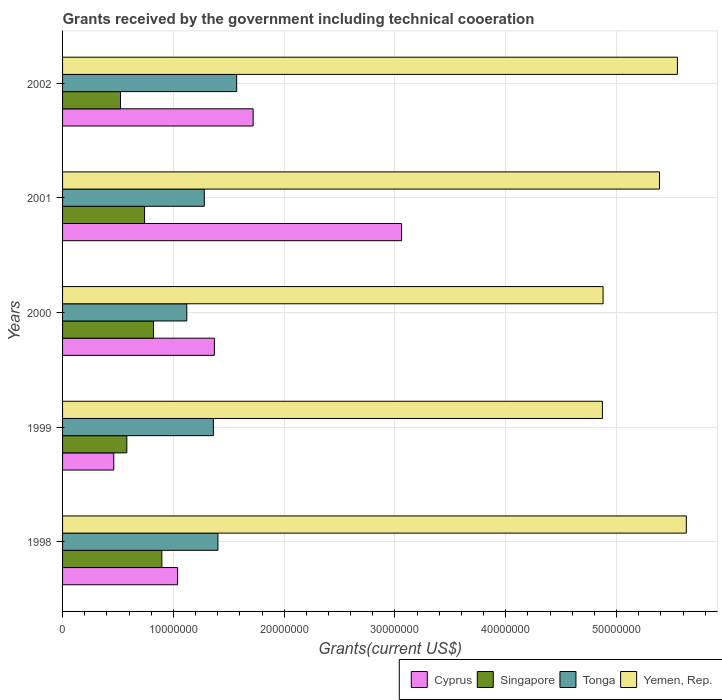How many different coloured bars are there?
Offer a terse response. 4. Are the number of bars per tick equal to the number of legend labels?
Your response must be concise. Yes. Are the number of bars on each tick of the Y-axis equal?
Keep it short and to the point. Yes. How many bars are there on the 2nd tick from the top?
Give a very brief answer. 4. In how many cases, is the number of bars for a given year not equal to the number of legend labels?
Offer a very short reply. 0. What is the total grants received by the government in Singapore in 2001?
Ensure brevity in your answer.  7.40e+06. Across all years, what is the maximum total grants received by the government in Yemen, Rep.?
Give a very brief answer. 5.63e+07. Across all years, what is the minimum total grants received by the government in Yemen, Rep.?
Offer a very short reply. 4.87e+07. In which year was the total grants received by the government in Yemen, Rep. maximum?
Your answer should be compact. 1998. In which year was the total grants received by the government in Singapore minimum?
Provide a short and direct response. 2002. What is the total total grants received by the government in Yemen, Rep. in the graph?
Make the answer very short. 2.63e+08. What is the difference between the total grants received by the government in Yemen, Rep. in 1998 and that in 2000?
Make the answer very short. 7.51e+06. What is the difference between the total grants received by the government in Yemen, Rep. in 2001 and the total grants received by the government in Cyprus in 2002?
Your response must be concise. 3.67e+07. What is the average total grants received by the government in Tonga per year?
Offer a very short reply. 1.35e+07. In the year 2001, what is the difference between the total grants received by the government in Yemen, Rep. and total grants received by the government in Cyprus?
Your answer should be compact. 2.33e+07. What is the ratio of the total grants received by the government in Cyprus in 1999 to that in 2002?
Keep it short and to the point. 0.27. Is the difference between the total grants received by the government in Yemen, Rep. in 1999 and 2001 greater than the difference between the total grants received by the government in Cyprus in 1999 and 2001?
Make the answer very short. Yes. What is the difference between the highest and the second highest total grants received by the government in Yemen, Rep.?
Ensure brevity in your answer.  8.00e+05. What is the difference between the highest and the lowest total grants received by the government in Yemen, Rep.?
Provide a succinct answer. 7.57e+06. Is the sum of the total grants received by the government in Cyprus in 1999 and 2000 greater than the maximum total grants received by the government in Singapore across all years?
Make the answer very short. Yes. Is it the case that in every year, the sum of the total grants received by the government in Cyprus and total grants received by the government in Singapore is greater than the sum of total grants received by the government in Tonga and total grants received by the government in Yemen, Rep.?
Your answer should be very brief. No. What does the 2nd bar from the top in 1998 represents?
Ensure brevity in your answer.  Tonga. What does the 2nd bar from the bottom in 1999 represents?
Your answer should be compact. Singapore. How many bars are there?
Your answer should be very brief. 20. Are all the bars in the graph horizontal?
Provide a short and direct response. Yes. Are the values on the major ticks of X-axis written in scientific E-notation?
Your answer should be very brief. No. Does the graph contain any zero values?
Your answer should be very brief. No. Where does the legend appear in the graph?
Offer a very short reply. Bottom right. What is the title of the graph?
Provide a short and direct response. Grants received by the government including technical cooeration. Does "Czech Republic" appear as one of the legend labels in the graph?
Offer a very short reply. No. What is the label or title of the X-axis?
Your answer should be compact. Grants(current US$). What is the Grants(current US$) of Cyprus in 1998?
Provide a succinct answer. 1.04e+07. What is the Grants(current US$) in Singapore in 1998?
Your answer should be compact. 8.96e+06. What is the Grants(current US$) in Tonga in 1998?
Your response must be concise. 1.40e+07. What is the Grants(current US$) in Yemen, Rep. in 1998?
Provide a succinct answer. 5.63e+07. What is the Grants(current US$) in Cyprus in 1999?
Your answer should be compact. 4.62e+06. What is the Grants(current US$) in Singapore in 1999?
Provide a succinct answer. 5.80e+06. What is the Grants(current US$) of Tonga in 1999?
Offer a very short reply. 1.36e+07. What is the Grants(current US$) in Yemen, Rep. in 1999?
Provide a short and direct response. 4.87e+07. What is the Grants(current US$) in Cyprus in 2000?
Offer a terse response. 1.37e+07. What is the Grants(current US$) of Singapore in 2000?
Ensure brevity in your answer.  8.21e+06. What is the Grants(current US$) of Tonga in 2000?
Offer a terse response. 1.12e+07. What is the Grants(current US$) in Yemen, Rep. in 2000?
Ensure brevity in your answer.  4.88e+07. What is the Grants(current US$) in Cyprus in 2001?
Keep it short and to the point. 3.06e+07. What is the Grants(current US$) of Singapore in 2001?
Keep it short and to the point. 7.40e+06. What is the Grants(current US$) of Tonga in 2001?
Provide a short and direct response. 1.28e+07. What is the Grants(current US$) in Yemen, Rep. in 2001?
Keep it short and to the point. 5.39e+07. What is the Grants(current US$) of Cyprus in 2002?
Your answer should be compact. 1.72e+07. What is the Grants(current US$) in Singapore in 2002?
Ensure brevity in your answer.  5.23e+06. What is the Grants(current US$) of Tonga in 2002?
Ensure brevity in your answer.  1.57e+07. What is the Grants(current US$) in Yemen, Rep. in 2002?
Your response must be concise. 5.55e+07. Across all years, what is the maximum Grants(current US$) of Cyprus?
Provide a succinct answer. 3.06e+07. Across all years, what is the maximum Grants(current US$) of Singapore?
Offer a very short reply. 8.96e+06. Across all years, what is the maximum Grants(current US$) in Tonga?
Offer a very short reply. 1.57e+07. Across all years, what is the maximum Grants(current US$) in Yemen, Rep.?
Your answer should be compact. 5.63e+07. Across all years, what is the minimum Grants(current US$) of Cyprus?
Make the answer very short. 4.62e+06. Across all years, what is the minimum Grants(current US$) of Singapore?
Make the answer very short. 5.23e+06. Across all years, what is the minimum Grants(current US$) in Tonga?
Offer a terse response. 1.12e+07. Across all years, what is the minimum Grants(current US$) in Yemen, Rep.?
Your answer should be very brief. 4.87e+07. What is the total Grants(current US$) in Cyprus in the graph?
Provide a short and direct response. 7.65e+07. What is the total Grants(current US$) of Singapore in the graph?
Provide a short and direct response. 3.56e+07. What is the total Grants(current US$) of Tonga in the graph?
Offer a terse response. 6.73e+07. What is the total Grants(current US$) of Yemen, Rep. in the graph?
Make the answer very short. 2.63e+08. What is the difference between the Grants(current US$) in Cyprus in 1998 and that in 1999?
Ensure brevity in your answer.  5.76e+06. What is the difference between the Grants(current US$) of Singapore in 1998 and that in 1999?
Your answer should be compact. 3.16e+06. What is the difference between the Grants(current US$) of Yemen, Rep. in 1998 and that in 1999?
Your answer should be very brief. 7.57e+06. What is the difference between the Grants(current US$) of Cyprus in 1998 and that in 2000?
Your answer should be very brief. -3.32e+06. What is the difference between the Grants(current US$) in Singapore in 1998 and that in 2000?
Provide a succinct answer. 7.50e+05. What is the difference between the Grants(current US$) in Tonga in 1998 and that in 2000?
Provide a succinct answer. 2.81e+06. What is the difference between the Grants(current US$) in Yemen, Rep. in 1998 and that in 2000?
Your answer should be compact. 7.51e+06. What is the difference between the Grants(current US$) of Cyprus in 1998 and that in 2001?
Your answer should be compact. -2.02e+07. What is the difference between the Grants(current US$) in Singapore in 1998 and that in 2001?
Your answer should be very brief. 1.56e+06. What is the difference between the Grants(current US$) of Tonga in 1998 and that in 2001?
Your answer should be very brief. 1.23e+06. What is the difference between the Grants(current US$) in Yemen, Rep. in 1998 and that in 2001?
Your answer should be very brief. 2.42e+06. What is the difference between the Grants(current US$) of Cyprus in 1998 and that in 2002?
Ensure brevity in your answer.  -6.82e+06. What is the difference between the Grants(current US$) in Singapore in 1998 and that in 2002?
Offer a very short reply. 3.73e+06. What is the difference between the Grants(current US$) in Tonga in 1998 and that in 2002?
Provide a short and direct response. -1.69e+06. What is the difference between the Grants(current US$) in Yemen, Rep. in 1998 and that in 2002?
Ensure brevity in your answer.  8.00e+05. What is the difference between the Grants(current US$) in Cyprus in 1999 and that in 2000?
Offer a terse response. -9.08e+06. What is the difference between the Grants(current US$) in Singapore in 1999 and that in 2000?
Your answer should be compact. -2.41e+06. What is the difference between the Grants(current US$) in Tonga in 1999 and that in 2000?
Offer a terse response. 2.40e+06. What is the difference between the Grants(current US$) of Yemen, Rep. in 1999 and that in 2000?
Make the answer very short. -6.00e+04. What is the difference between the Grants(current US$) of Cyprus in 1999 and that in 2001?
Offer a very short reply. -2.60e+07. What is the difference between the Grants(current US$) in Singapore in 1999 and that in 2001?
Provide a succinct answer. -1.60e+06. What is the difference between the Grants(current US$) of Tonga in 1999 and that in 2001?
Your response must be concise. 8.20e+05. What is the difference between the Grants(current US$) in Yemen, Rep. in 1999 and that in 2001?
Your response must be concise. -5.15e+06. What is the difference between the Grants(current US$) of Cyprus in 1999 and that in 2002?
Provide a succinct answer. -1.26e+07. What is the difference between the Grants(current US$) in Singapore in 1999 and that in 2002?
Your response must be concise. 5.70e+05. What is the difference between the Grants(current US$) of Tonga in 1999 and that in 2002?
Keep it short and to the point. -2.10e+06. What is the difference between the Grants(current US$) in Yemen, Rep. in 1999 and that in 2002?
Offer a terse response. -6.77e+06. What is the difference between the Grants(current US$) of Cyprus in 2000 and that in 2001?
Offer a very short reply. -1.69e+07. What is the difference between the Grants(current US$) of Singapore in 2000 and that in 2001?
Keep it short and to the point. 8.10e+05. What is the difference between the Grants(current US$) in Tonga in 2000 and that in 2001?
Ensure brevity in your answer.  -1.58e+06. What is the difference between the Grants(current US$) of Yemen, Rep. in 2000 and that in 2001?
Your response must be concise. -5.09e+06. What is the difference between the Grants(current US$) in Cyprus in 2000 and that in 2002?
Keep it short and to the point. -3.50e+06. What is the difference between the Grants(current US$) in Singapore in 2000 and that in 2002?
Your answer should be compact. 2.98e+06. What is the difference between the Grants(current US$) of Tonga in 2000 and that in 2002?
Make the answer very short. -4.50e+06. What is the difference between the Grants(current US$) in Yemen, Rep. in 2000 and that in 2002?
Your response must be concise. -6.71e+06. What is the difference between the Grants(current US$) of Cyprus in 2001 and that in 2002?
Provide a succinct answer. 1.34e+07. What is the difference between the Grants(current US$) of Singapore in 2001 and that in 2002?
Provide a short and direct response. 2.17e+06. What is the difference between the Grants(current US$) of Tonga in 2001 and that in 2002?
Offer a terse response. -2.92e+06. What is the difference between the Grants(current US$) of Yemen, Rep. in 2001 and that in 2002?
Your answer should be very brief. -1.62e+06. What is the difference between the Grants(current US$) of Cyprus in 1998 and the Grants(current US$) of Singapore in 1999?
Ensure brevity in your answer.  4.58e+06. What is the difference between the Grants(current US$) of Cyprus in 1998 and the Grants(current US$) of Tonga in 1999?
Offer a very short reply. -3.23e+06. What is the difference between the Grants(current US$) of Cyprus in 1998 and the Grants(current US$) of Yemen, Rep. in 1999?
Your answer should be very brief. -3.83e+07. What is the difference between the Grants(current US$) in Singapore in 1998 and the Grants(current US$) in Tonga in 1999?
Ensure brevity in your answer.  -4.65e+06. What is the difference between the Grants(current US$) of Singapore in 1998 and the Grants(current US$) of Yemen, Rep. in 1999?
Give a very brief answer. -3.98e+07. What is the difference between the Grants(current US$) of Tonga in 1998 and the Grants(current US$) of Yemen, Rep. in 1999?
Your answer should be very brief. -3.47e+07. What is the difference between the Grants(current US$) of Cyprus in 1998 and the Grants(current US$) of Singapore in 2000?
Offer a very short reply. 2.17e+06. What is the difference between the Grants(current US$) of Cyprus in 1998 and the Grants(current US$) of Tonga in 2000?
Your answer should be compact. -8.30e+05. What is the difference between the Grants(current US$) of Cyprus in 1998 and the Grants(current US$) of Yemen, Rep. in 2000?
Provide a succinct answer. -3.84e+07. What is the difference between the Grants(current US$) of Singapore in 1998 and the Grants(current US$) of Tonga in 2000?
Keep it short and to the point. -2.25e+06. What is the difference between the Grants(current US$) in Singapore in 1998 and the Grants(current US$) in Yemen, Rep. in 2000?
Your answer should be compact. -3.98e+07. What is the difference between the Grants(current US$) of Tonga in 1998 and the Grants(current US$) of Yemen, Rep. in 2000?
Make the answer very short. -3.48e+07. What is the difference between the Grants(current US$) of Cyprus in 1998 and the Grants(current US$) of Singapore in 2001?
Keep it short and to the point. 2.98e+06. What is the difference between the Grants(current US$) of Cyprus in 1998 and the Grants(current US$) of Tonga in 2001?
Provide a short and direct response. -2.41e+06. What is the difference between the Grants(current US$) of Cyprus in 1998 and the Grants(current US$) of Yemen, Rep. in 2001?
Ensure brevity in your answer.  -4.35e+07. What is the difference between the Grants(current US$) of Singapore in 1998 and the Grants(current US$) of Tonga in 2001?
Keep it short and to the point. -3.83e+06. What is the difference between the Grants(current US$) in Singapore in 1998 and the Grants(current US$) in Yemen, Rep. in 2001?
Your answer should be compact. -4.49e+07. What is the difference between the Grants(current US$) in Tonga in 1998 and the Grants(current US$) in Yemen, Rep. in 2001?
Make the answer very short. -3.98e+07. What is the difference between the Grants(current US$) in Cyprus in 1998 and the Grants(current US$) in Singapore in 2002?
Offer a very short reply. 5.15e+06. What is the difference between the Grants(current US$) in Cyprus in 1998 and the Grants(current US$) in Tonga in 2002?
Give a very brief answer. -5.33e+06. What is the difference between the Grants(current US$) of Cyprus in 1998 and the Grants(current US$) of Yemen, Rep. in 2002?
Provide a short and direct response. -4.51e+07. What is the difference between the Grants(current US$) of Singapore in 1998 and the Grants(current US$) of Tonga in 2002?
Provide a succinct answer. -6.75e+06. What is the difference between the Grants(current US$) in Singapore in 1998 and the Grants(current US$) in Yemen, Rep. in 2002?
Your response must be concise. -4.65e+07. What is the difference between the Grants(current US$) of Tonga in 1998 and the Grants(current US$) of Yemen, Rep. in 2002?
Ensure brevity in your answer.  -4.15e+07. What is the difference between the Grants(current US$) of Cyprus in 1999 and the Grants(current US$) of Singapore in 2000?
Keep it short and to the point. -3.59e+06. What is the difference between the Grants(current US$) in Cyprus in 1999 and the Grants(current US$) in Tonga in 2000?
Give a very brief answer. -6.59e+06. What is the difference between the Grants(current US$) of Cyprus in 1999 and the Grants(current US$) of Yemen, Rep. in 2000?
Your response must be concise. -4.42e+07. What is the difference between the Grants(current US$) in Singapore in 1999 and the Grants(current US$) in Tonga in 2000?
Offer a terse response. -5.41e+06. What is the difference between the Grants(current US$) in Singapore in 1999 and the Grants(current US$) in Yemen, Rep. in 2000?
Your answer should be compact. -4.30e+07. What is the difference between the Grants(current US$) in Tonga in 1999 and the Grants(current US$) in Yemen, Rep. in 2000?
Give a very brief answer. -3.52e+07. What is the difference between the Grants(current US$) in Cyprus in 1999 and the Grants(current US$) in Singapore in 2001?
Offer a terse response. -2.78e+06. What is the difference between the Grants(current US$) in Cyprus in 1999 and the Grants(current US$) in Tonga in 2001?
Ensure brevity in your answer.  -8.17e+06. What is the difference between the Grants(current US$) of Cyprus in 1999 and the Grants(current US$) of Yemen, Rep. in 2001?
Your answer should be very brief. -4.92e+07. What is the difference between the Grants(current US$) in Singapore in 1999 and the Grants(current US$) in Tonga in 2001?
Your answer should be very brief. -6.99e+06. What is the difference between the Grants(current US$) in Singapore in 1999 and the Grants(current US$) in Yemen, Rep. in 2001?
Provide a short and direct response. -4.81e+07. What is the difference between the Grants(current US$) in Tonga in 1999 and the Grants(current US$) in Yemen, Rep. in 2001?
Provide a succinct answer. -4.03e+07. What is the difference between the Grants(current US$) of Cyprus in 1999 and the Grants(current US$) of Singapore in 2002?
Your response must be concise. -6.10e+05. What is the difference between the Grants(current US$) in Cyprus in 1999 and the Grants(current US$) in Tonga in 2002?
Offer a terse response. -1.11e+07. What is the difference between the Grants(current US$) of Cyprus in 1999 and the Grants(current US$) of Yemen, Rep. in 2002?
Give a very brief answer. -5.09e+07. What is the difference between the Grants(current US$) in Singapore in 1999 and the Grants(current US$) in Tonga in 2002?
Provide a short and direct response. -9.91e+06. What is the difference between the Grants(current US$) of Singapore in 1999 and the Grants(current US$) of Yemen, Rep. in 2002?
Provide a succinct answer. -4.97e+07. What is the difference between the Grants(current US$) of Tonga in 1999 and the Grants(current US$) of Yemen, Rep. in 2002?
Make the answer very short. -4.19e+07. What is the difference between the Grants(current US$) in Cyprus in 2000 and the Grants(current US$) in Singapore in 2001?
Your response must be concise. 6.30e+06. What is the difference between the Grants(current US$) in Cyprus in 2000 and the Grants(current US$) in Tonga in 2001?
Your answer should be very brief. 9.10e+05. What is the difference between the Grants(current US$) in Cyprus in 2000 and the Grants(current US$) in Yemen, Rep. in 2001?
Your response must be concise. -4.02e+07. What is the difference between the Grants(current US$) in Singapore in 2000 and the Grants(current US$) in Tonga in 2001?
Give a very brief answer. -4.58e+06. What is the difference between the Grants(current US$) of Singapore in 2000 and the Grants(current US$) of Yemen, Rep. in 2001?
Keep it short and to the point. -4.57e+07. What is the difference between the Grants(current US$) of Tonga in 2000 and the Grants(current US$) of Yemen, Rep. in 2001?
Ensure brevity in your answer.  -4.27e+07. What is the difference between the Grants(current US$) of Cyprus in 2000 and the Grants(current US$) of Singapore in 2002?
Make the answer very short. 8.47e+06. What is the difference between the Grants(current US$) of Cyprus in 2000 and the Grants(current US$) of Tonga in 2002?
Make the answer very short. -2.01e+06. What is the difference between the Grants(current US$) in Cyprus in 2000 and the Grants(current US$) in Yemen, Rep. in 2002?
Provide a succinct answer. -4.18e+07. What is the difference between the Grants(current US$) of Singapore in 2000 and the Grants(current US$) of Tonga in 2002?
Make the answer very short. -7.50e+06. What is the difference between the Grants(current US$) in Singapore in 2000 and the Grants(current US$) in Yemen, Rep. in 2002?
Give a very brief answer. -4.73e+07. What is the difference between the Grants(current US$) in Tonga in 2000 and the Grants(current US$) in Yemen, Rep. in 2002?
Provide a succinct answer. -4.43e+07. What is the difference between the Grants(current US$) in Cyprus in 2001 and the Grants(current US$) in Singapore in 2002?
Ensure brevity in your answer.  2.54e+07. What is the difference between the Grants(current US$) in Cyprus in 2001 and the Grants(current US$) in Tonga in 2002?
Provide a succinct answer. 1.49e+07. What is the difference between the Grants(current US$) of Cyprus in 2001 and the Grants(current US$) of Yemen, Rep. in 2002?
Keep it short and to the point. -2.49e+07. What is the difference between the Grants(current US$) in Singapore in 2001 and the Grants(current US$) in Tonga in 2002?
Keep it short and to the point. -8.31e+06. What is the difference between the Grants(current US$) in Singapore in 2001 and the Grants(current US$) in Yemen, Rep. in 2002?
Ensure brevity in your answer.  -4.81e+07. What is the difference between the Grants(current US$) in Tonga in 2001 and the Grants(current US$) in Yemen, Rep. in 2002?
Your answer should be compact. -4.27e+07. What is the average Grants(current US$) in Cyprus per year?
Your answer should be very brief. 1.53e+07. What is the average Grants(current US$) in Singapore per year?
Offer a terse response. 7.12e+06. What is the average Grants(current US$) in Tonga per year?
Ensure brevity in your answer.  1.35e+07. What is the average Grants(current US$) of Yemen, Rep. per year?
Your response must be concise. 5.26e+07. In the year 1998, what is the difference between the Grants(current US$) in Cyprus and Grants(current US$) in Singapore?
Your response must be concise. 1.42e+06. In the year 1998, what is the difference between the Grants(current US$) in Cyprus and Grants(current US$) in Tonga?
Offer a very short reply. -3.64e+06. In the year 1998, what is the difference between the Grants(current US$) of Cyprus and Grants(current US$) of Yemen, Rep.?
Keep it short and to the point. -4.59e+07. In the year 1998, what is the difference between the Grants(current US$) of Singapore and Grants(current US$) of Tonga?
Ensure brevity in your answer.  -5.06e+06. In the year 1998, what is the difference between the Grants(current US$) of Singapore and Grants(current US$) of Yemen, Rep.?
Offer a terse response. -4.73e+07. In the year 1998, what is the difference between the Grants(current US$) of Tonga and Grants(current US$) of Yemen, Rep.?
Keep it short and to the point. -4.23e+07. In the year 1999, what is the difference between the Grants(current US$) in Cyprus and Grants(current US$) in Singapore?
Make the answer very short. -1.18e+06. In the year 1999, what is the difference between the Grants(current US$) in Cyprus and Grants(current US$) in Tonga?
Ensure brevity in your answer.  -8.99e+06. In the year 1999, what is the difference between the Grants(current US$) of Cyprus and Grants(current US$) of Yemen, Rep.?
Offer a very short reply. -4.41e+07. In the year 1999, what is the difference between the Grants(current US$) of Singapore and Grants(current US$) of Tonga?
Make the answer very short. -7.81e+06. In the year 1999, what is the difference between the Grants(current US$) of Singapore and Grants(current US$) of Yemen, Rep.?
Offer a very short reply. -4.29e+07. In the year 1999, what is the difference between the Grants(current US$) of Tonga and Grants(current US$) of Yemen, Rep.?
Your answer should be very brief. -3.51e+07. In the year 2000, what is the difference between the Grants(current US$) of Cyprus and Grants(current US$) of Singapore?
Your response must be concise. 5.49e+06. In the year 2000, what is the difference between the Grants(current US$) of Cyprus and Grants(current US$) of Tonga?
Make the answer very short. 2.49e+06. In the year 2000, what is the difference between the Grants(current US$) in Cyprus and Grants(current US$) in Yemen, Rep.?
Provide a succinct answer. -3.51e+07. In the year 2000, what is the difference between the Grants(current US$) of Singapore and Grants(current US$) of Tonga?
Your answer should be compact. -3.00e+06. In the year 2000, what is the difference between the Grants(current US$) of Singapore and Grants(current US$) of Yemen, Rep.?
Make the answer very short. -4.06e+07. In the year 2000, what is the difference between the Grants(current US$) of Tonga and Grants(current US$) of Yemen, Rep.?
Provide a succinct answer. -3.76e+07. In the year 2001, what is the difference between the Grants(current US$) in Cyprus and Grants(current US$) in Singapore?
Ensure brevity in your answer.  2.32e+07. In the year 2001, what is the difference between the Grants(current US$) of Cyprus and Grants(current US$) of Tonga?
Keep it short and to the point. 1.78e+07. In the year 2001, what is the difference between the Grants(current US$) in Cyprus and Grants(current US$) in Yemen, Rep.?
Ensure brevity in your answer.  -2.33e+07. In the year 2001, what is the difference between the Grants(current US$) in Singapore and Grants(current US$) in Tonga?
Offer a terse response. -5.39e+06. In the year 2001, what is the difference between the Grants(current US$) in Singapore and Grants(current US$) in Yemen, Rep.?
Provide a succinct answer. -4.65e+07. In the year 2001, what is the difference between the Grants(current US$) of Tonga and Grants(current US$) of Yemen, Rep.?
Offer a terse response. -4.11e+07. In the year 2002, what is the difference between the Grants(current US$) in Cyprus and Grants(current US$) in Singapore?
Ensure brevity in your answer.  1.20e+07. In the year 2002, what is the difference between the Grants(current US$) of Cyprus and Grants(current US$) of Tonga?
Your response must be concise. 1.49e+06. In the year 2002, what is the difference between the Grants(current US$) in Cyprus and Grants(current US$) in Yemen, Rep.?
Your answer should be compact. -3.83e+07. In the year 2002, what is the difference between the Grants(current US$) in Singapore and Grants(current US$) in Tonga?
Your response must be concise. -1.05e+07. In the year 2002, what is the difference between the Grants(current US$) in Singapore and Grants(current US$) in Yemen, Rep.?
Your response must be concise. -5.03e+07. In the year 2002, what is the difference between the Grants(current US$) in Tonga and Grants(current US$) in Yemen, Rep.?
Your answer should be compact. -3.98e+07. What is the ratio of the Grants(current US$) in Cyprus in 1998 to that in 1999?
Ensure brevity in your answer.  2.25. What is the ratio of the Grants(current US$) in Singapore in 1998 to that in 1999?
Provide a short and direct response. 1.54. What is the ratio of the Grants(current US$) in Tonga in 1998 to that in 1999?
Ensure brevity in your answer.  1.03. What is the ratio of the Grants(current US$) of Yemen, Rep. in 1998 to that in 1999?
Offer a very short reply. 1.16. What is the ratio of the Grants(current US$) of Cyprus in 1998 to that in 2000?
Offer a very short reply. 0.76. What is the ratio of the Grants(current US$) in Singapore in 1998 to that in 2000?
Make the answer very short. 1.09. What is the ratio of the Grants(current US$) in Tonga in 1998 to that in 2000?
Ensure brevity in your answer.  1.25. What is the ratio of the Grants(current US$) of Yemen, Rep. in 1998 to that in 2000?
Offer a terse response. 1.15. What is the ratio of the Grants(current US$) in Cyprus in 1998 to that in 2001?
Your answer should be compact. 0.34. What is the ratio of the Grants(current US$) of Singapore in 1998 to that in 2001?
Your response must be concise. 1.21. What is the ratio of the Grants(current US$) of Tonga in 1998 to that in 2001?
Your answer should be very brief. 1.1. What is the ratio of the Grants(current US$) of Yemen, Rep. in 1998 to that in 2001?
Provide a short and direct response. 1.04. What is the ratio of the Grants(current US$) in Cyprus in 1998 to that in 2002?
Offer a very short reply. 0.6. What is the ratio of the Grants(current US$) in Singapore in 1998 to that in 2002?
Keep it short and to the point. 1.71. What is the ratio of the Grants(current US$) of Tonga in 1998 to that in 2002?
Provide a succinct answer. 0.89. What is the ratio of the Grants(current US$) of Yemen, Rep. in 1998 to that in 2002?
Your response must be concise. 1.01. What is the ratio of the Grants(current US$) of Cyprus in 1999 to that in 2000?
Make the answer very short. 0.34. What is the ratio of the Grants(current US$) of Singapore in 1999 to that in 2000?
Offer a terse response. 0.71. What is the ratio of the Grants(current US$) of Tonga in 1999 to that in 2000?
Your answer should be very brief. 1.21. What is the ratio of the Grants(current US$) of Cyprus in 1999 to that in 2001?
Your answer should be compact. 0.15. What is the ratio of the Grants(current US$) of Singapore in 1999 to that in 2001?
Offer a terse response. 0.78. What is the ratio of the Grants(current US$) in Tonga in 1999 to that in 2001?
Provide a succinct answer. 1.06. What is the ratio of the Grants(current US$) in Yemen, Rep. in 1999 to that in 2001?
Provide a short and direct response. 0.9. What is the ratio of the Grants(current US$) in Cyprus in 1999 to that in 2002?
Offer a terse response. 0.27. What is the ratio of the Grants(current US$) in Singapore in 1999 to that in 2002?
Your answer should be compact. 1.11. What is the ratio of the Grants(current US$) of Tonga in 1999 to that in 2002?
Offer a terse response. 0.87. What is the ratio of the Grants(current US$) in Yemen, Rep. in 1999 to that in 2002?
Your answer should be compact. 0.88. What is the ratio of the Grants(current US$) of Cyprus in 2000 to that in 2001?
Provide a short and direct response. 0.45. What is the ratio of the Grants(current US$) of Singapore in 2000 to that in 2001?
Provide a succinct answer. 1.11. What is the ratio of the Grants(current US$) of Tonga in 2000 to that in 2001?
Your answer should be very brief. 0.88. What is the ratio of the Grants(current US$) of Yemen, Rep. in 2000 to that in 2001?
Offer a very short reply. 0.91. What is the ratio of the Grants(current US$) of Cyprus in 2000 to that in 2002?
Ensure brevity in your answer.  0.8. What is the ratio of the Grants(current US$) in Singapore in 2000 to that in 2002?
Your answer should be very brief. 1.57. What is the ratio of the Grants(current US$) in Tonga in 2000 to that in 2002?
Ensure brevity in your answer.  0.71. What is the ratio of the Grants(current US$) of Yemen, Rep. in 2000 to that in 2002?
Provide a short and direct response. 0.88. What is the ratio of the Grants(current US$) of Cyprus in 2001 to that in 2002?
Offer a very short reply. 1.78. What is the ratio of the Grants(current US$) of Singapore in 2001 to that in 2002?
Give a very brief answer. 1.41. What is the ratio of the Grants(current US$) in Tonga in 2001 to that in 2002?
Provide a short and direct response. 0.81. What is the ratio of the Grants(current US$) of Yemen, Rep. in 2001 to that in 2002?
Provide a short and direct response. 0.97. What is the difference between the highest and the second highest Grants(current US$) in Cyprus?
Your answer should be compact. 1.34e+07. What is the difference between the highest and the second highest Grants(current US$) in Singapore?
Ensure brevity in your answer.  7.50e+05. What is the difference between the highest and the second highest Grants(current US$) in Tonga?
Make the answer very short. 1.69e+06. What is the difference between the highest and the second highest Grants(current US$) of Yemen, Rep.?
Ensure brevity in your answer.  8.00e+05. What is the difference between the highest and the lowest Grants(current US$) of Cyprus?
Make the answer very short. 2.60e+07. What is the difference between the highest and the lowest Grants(current US$) in Singapore?
Provide a succinct answer. 3.73e+06. What is the difference between the highest and the lowest Grants(current US$) of Tonga?
Offer a terse response. 4.50e+06. What is the difference between the highest and the lowest Grants(current US$) in Yemen, Rep.?
Make the answer very short. 7.57e+06. 